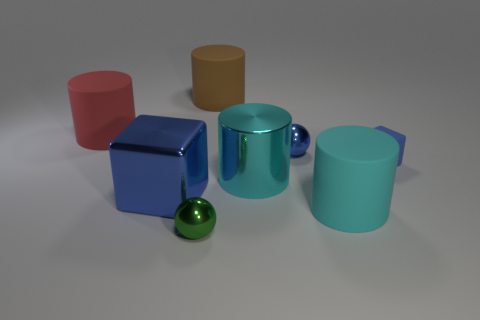How do the objects seem to be arranged in terms of depth? The objects are arranged with a sense of depth; the red cube is closest to the viewer, followed by the blue cube, the green metallic cylinder, the yellow cylinder, and the pale blue mug further away. This arrangement creates a staircase-like progression into the scene, with each object's size and overlap helping to perceive their relative positions in space. 